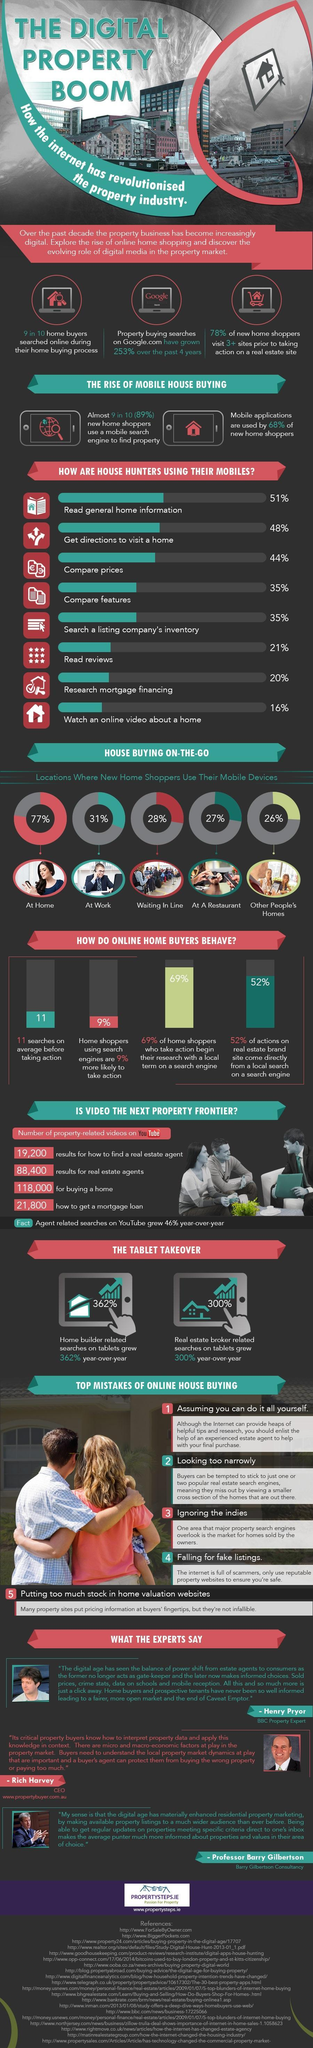Indicate a few pertinent items in this graphic. According to a study, 77% of home shoppers use their mobile devices while at home. According to a recent study, 21% of home buyers read reviews on their mobile devices. Nine out of ten home shoppers searched for information online during their home buying process. According to a recent study, 31% of new home buyers use their mobile devices from work while making their home-buying decisions. The growth in home builder-related search on tablets was significant, increasing by 362% compared to the previous year. 